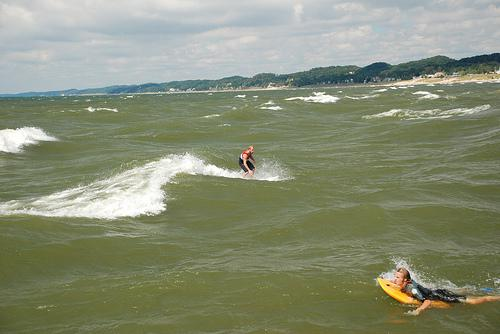Question: where was the picture taken?
Choices:
A. Home.
B. Beach.
C. Mountain.
D. Park.
Answer with the letter. Answer: B Question: what is the man in background doing?
Choices:
A. Surfing.
B. Swimming.
C. Playing softball.
D. Dancing.
Answer with the letter. Answer: A Question: who are in the picture?
Choices:
A. People.
B. Cows.
C. Dogs.
D. Mice.
Answer with the letter. Answer: A Question: what is in the sky?
Choices:
A. An airplane.
B. Clouds.
C. A balloon.
D. A flock of birds.
Answer with the letter. Answer: B Question: how many people are in the photograph?
Choices:
A. Three.
B. Four.
C. Five.
D. Two.
Answer with the letter. Answer: D 